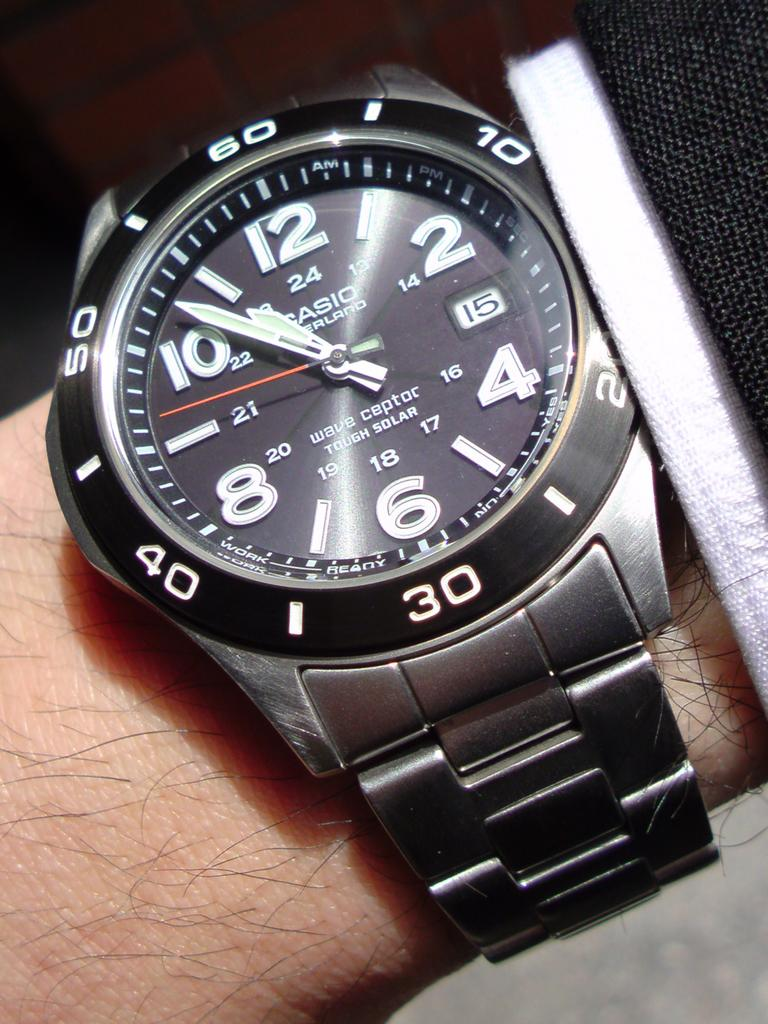What part of the human body is visible in the image? There is a human hand in the image. What object is being held by the hand in the image? There is a watch in the image. What color is the watch? The watch is gray in color. How many frogs are sitting on the watch in the image? There are no frogs present in the image, and therefore no frogs are sitting on the watch. What type of wax is being used to polish the watch in the image? There is no wax present in the image, and the watch's condition is not mentioned, so it cannot be determined if wax is being used to polish it. 